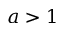<formula> <loc_0><loc_0><loc_500><loc_500>a > 1</formula> 